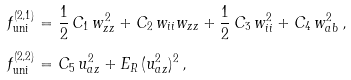Convert formula to latex. <formula><loc_0><loc_0><loc_500><loc_500>f _ { \text {uni} } ^ { ( 2 , 1 ) } & = \frac { 1 } { 2 } \, C _ { 1 } \, w _ { z z } ^ { 2 } + C _ { 2 } \, w _ { i i } w _ { z z } + \frac { 1 } { 2 } \, C _ { 3 } \, w _ { i i } ^ { 2 } + C _ { 4 } \, w _ { a b } ^ { 2 } \, , \\ f _ { \text {uni} } ^ { ( 2 , 2 ) } & = C _ { 5 } \, u _ { a z } ^ { 2 } + E _ { R } \, ( u _ { a z } ^ { 2 } ) ^ { 2 } \, ,</formula> 